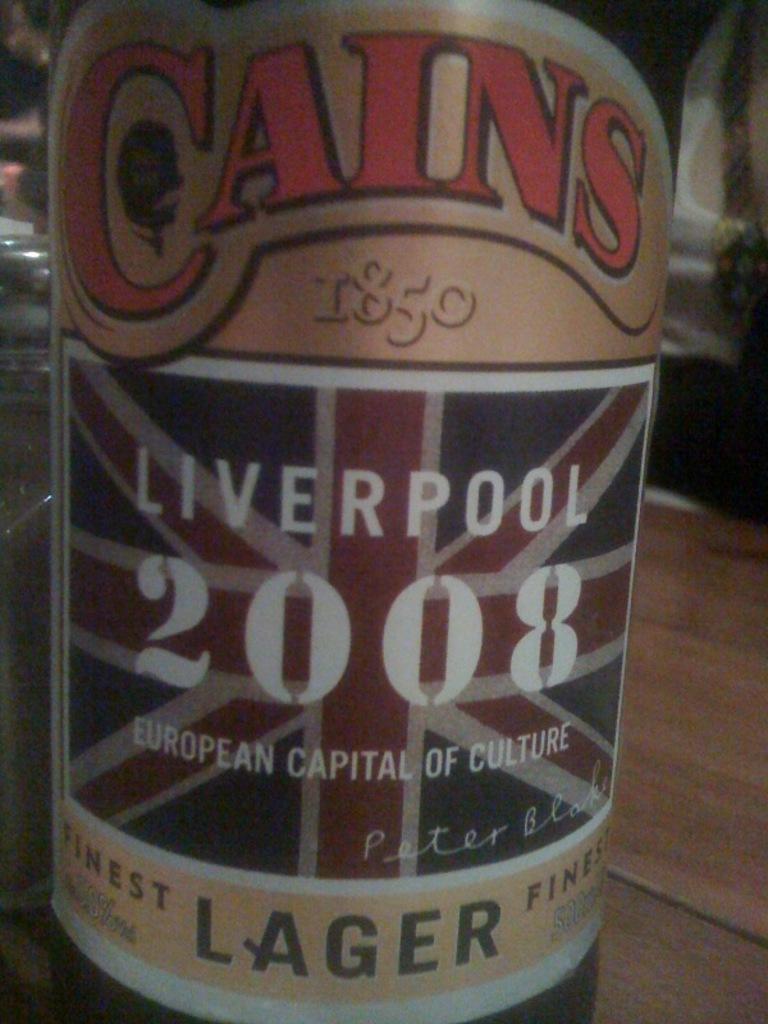What brand is the lager?
Ensure brevity in your answer.  Cains. What year is listed on the can under liverpool?
Your response must be concise. 2008. 